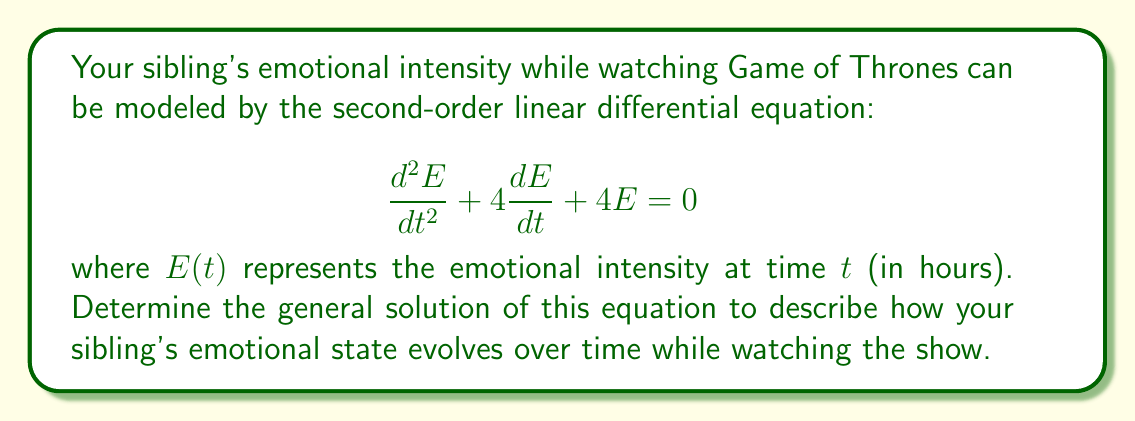Provide a solution to this math problem. To solve this second-order linear differential equation, we follow these steps:

1) First, we identify the characteristic equation:
   $$r^2 + 4r + 4 = 0$$

2) We solve this quadratic equation:
   $$(r + 2)^2 = 0$$
   $$r = -2$$ (repeated root)

3) When we have a repeated root, the general solution takes the form:
   $$E(t) = (c_1 + c_2t)e^{rt}$$
   where $c_1$ and $c_2$ are arbitrary constants and $r$ is the repeated root.

4) Substituting $r = -2$, we get:
   $$E(t) = (c_1 + c_2t)e^{-2t}$$

This solution represents your sibling's emotional intensity over time. The term $e^{-2t}$ indicates that the overall emotional intensity decreases exponentially over time, which could represent a gradual calming down after intense scenes. The linear term $(c_1 + c_2t)$ allows for some variation in this decay, potentially representing occasional spikes in emotion due to surprising plot twists or character deaths.
Answer: The general solution is:
$$E(t) = (c_1 + c_2t)e^{-2t}$$
where $c_1$ and $c_2$ are arbitrary constants. 